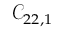<formula> <loc_0><loc_0><loc_500><loc_500>\mathcal { C } _ { 2 2 , 1 }</formula> 